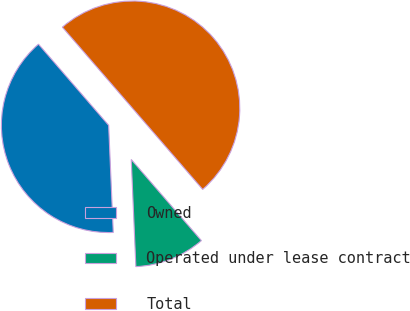<chart> <loc_0><loc_0><loc_500><loc_500><pie_chart><fcel>Owned<fcel>Operated under lease contract<fcel>Total<nl><fcel>39.34%<fcel>10.66%<fcel>50.0%<nl></chart> 